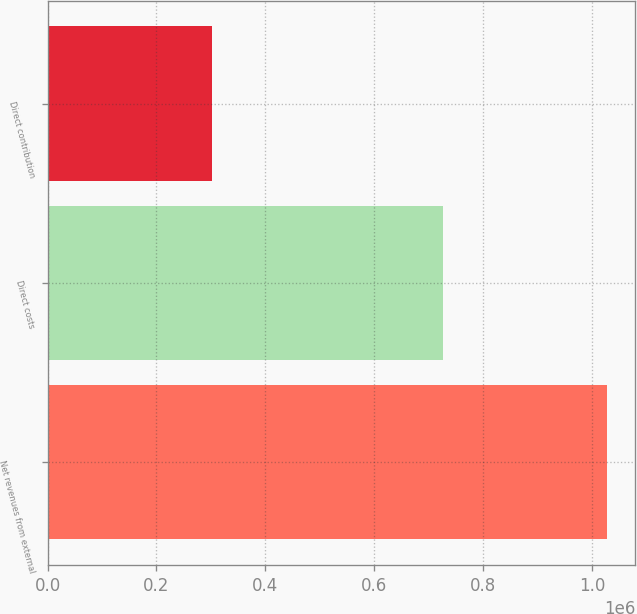Convert chart to OTSL. <chart><loc_0><loc_0><loc_500><loc_500><bar_chart><fcel>Net revenues from external<fcel>Direct costs<fcel>Direct contribution<nl><fcel>1.02846e+06<fcel>725616<fcel>302839<nl></chart> 